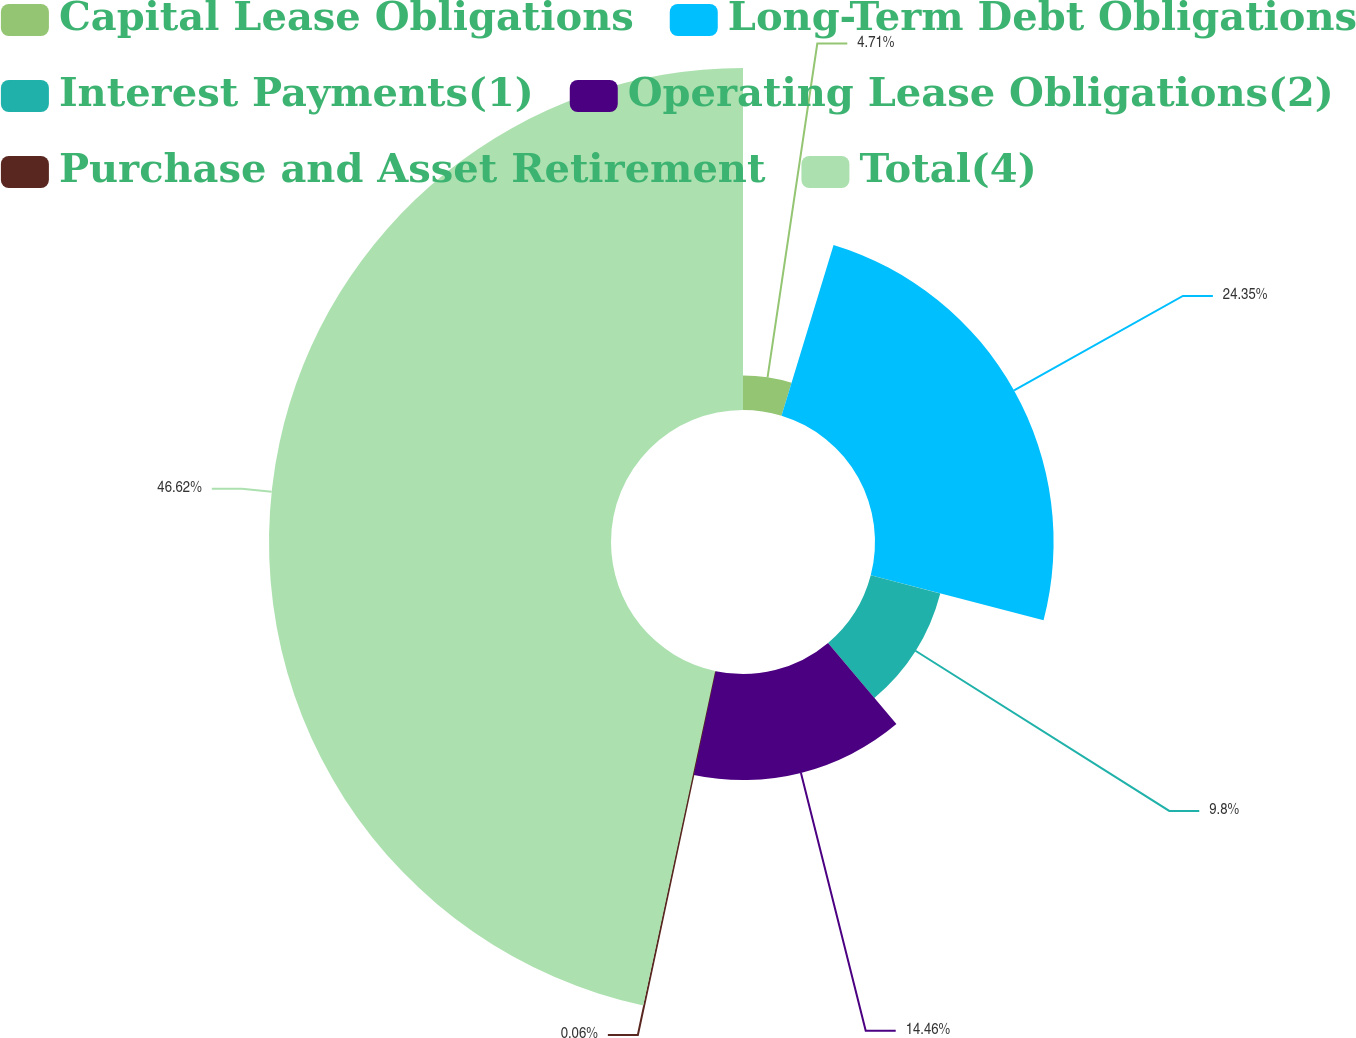Convert chart. <chart><loc_0><loc_0><loc_500><loc_500><pie_chart><fcel>Capital Lease Obligations<fcel>Long-Term Debt Obligations<fcel>Interest Payments(1)<fcel>Operating Lease Obligations(2)<fcel>Purchase and Asset Retirement<fcel>Total(4)<nl><fcel>4.71%<fcel>24.35%<fcel>9.8%<fcel>14.46%<fcel>0.06%<fcel>46.63%<nl></chart> 